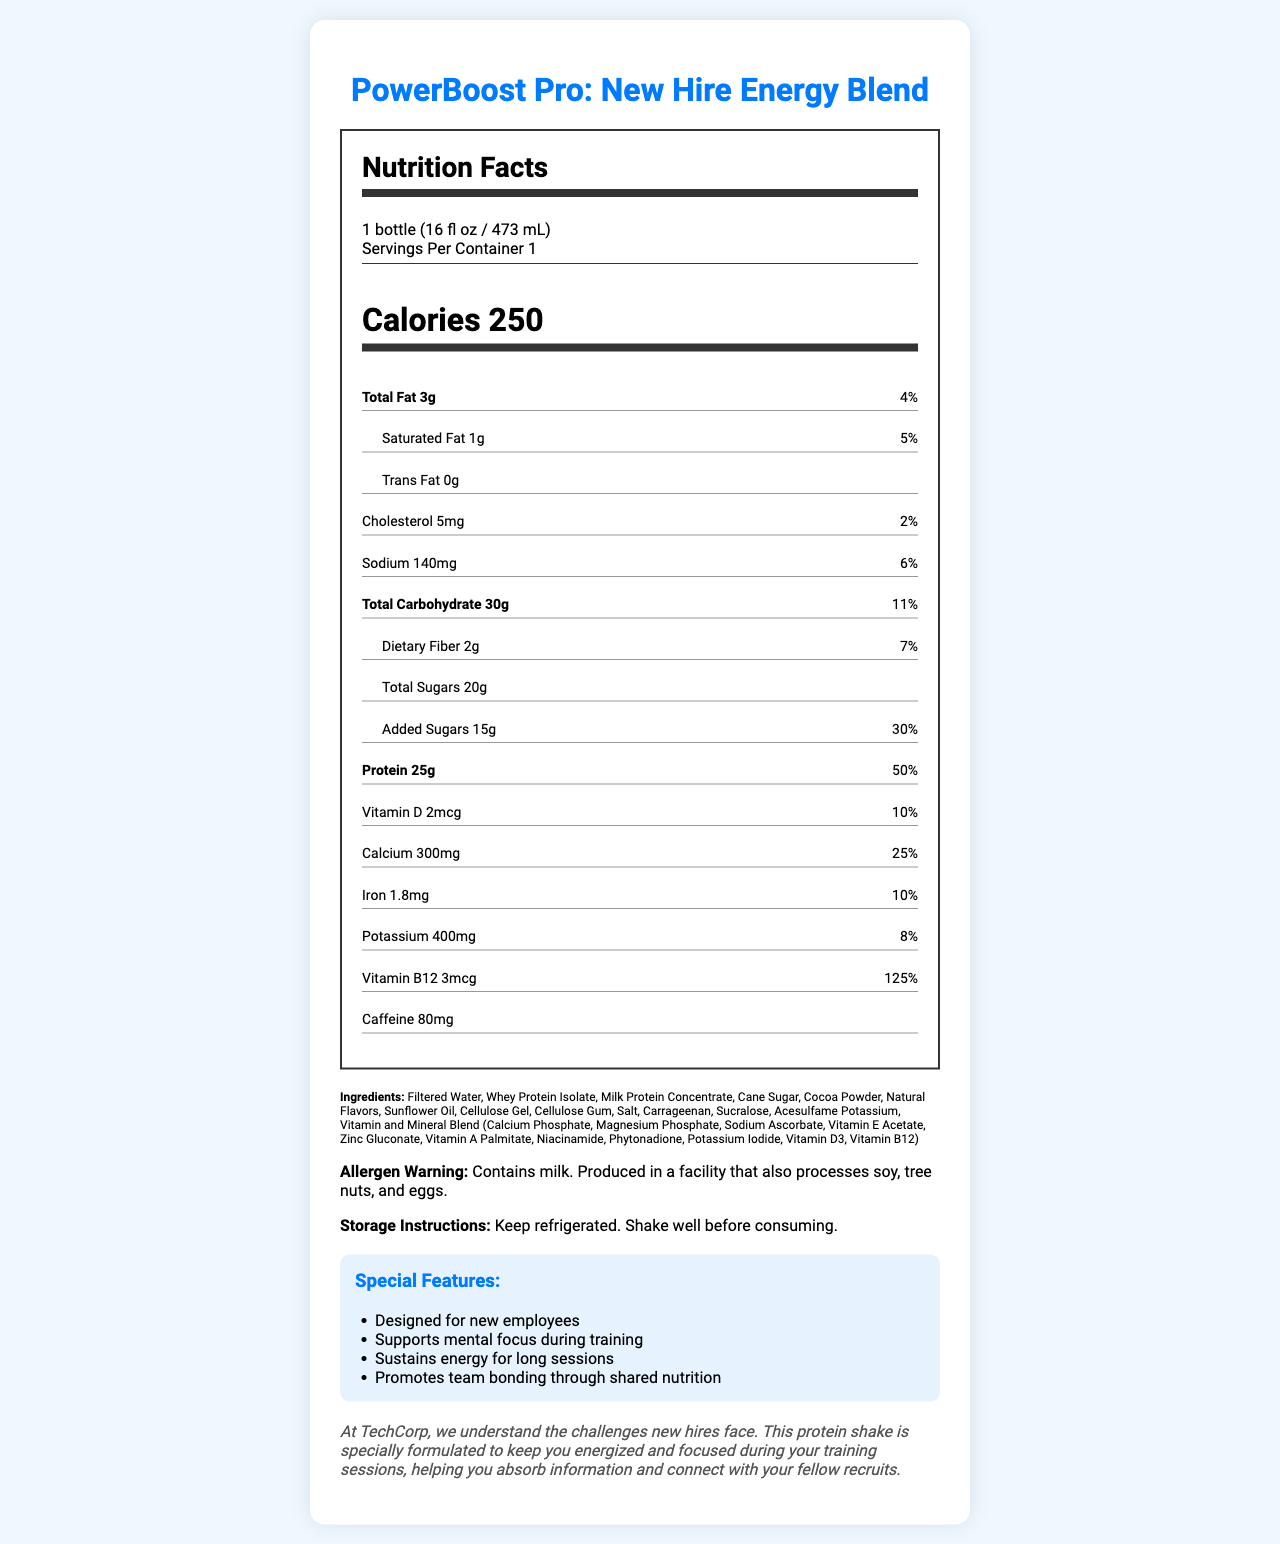what is the serving size for PowerBoost Pro: New Hire Energy Blend? The serving size is listed right below the product name at the top of the document.
Answer: 1 bottle (16 fl oz / 473 mL) how many calories are in one serving of PowerBoost Pro? The calories per serving are displayed prominently in a larger, bold font within the nutrition label section.
Answer: 250 what is the total fat content in the PowerBoost Pro? The total fat content is specifically listed in the nutrition facts section, just below the calories.
Answer: 3g how much protein does one serving of the PowerBoost Pro provide? The amount of protein per serving is displayed under the bold "Protein" label in the nutrition facts section.
Answer: 25g what is the caffeine content in the PowerBoost Pro? The caffeine content is clearly listed toward the bottom of the nutrition label.
Answer: 80mg does the PowerBoost Pro contain any vitamin B12? The nutrition label lists vitamin B12 with an amount of 3mcg and a daily value of 125%.
Answer: Yes what is the percentage of daily value for calcium provided by the PowerBoost Pro? The daily value percentage for calcium is listed in the nutrition facts section under calcium.
Answer: 25% which of the following ingredients is NOT included in the PowerBoost Pro?
A. Filtered Water
B. Soy Protein Isolate
C. Cocoa Powder Soy Protein Isolate is not listed among the ingredients. The correct options A and C are both listed.
Answer: B how much added sugars are in the PowerBoost Pro?
I. 10g
II. 15g
III. 20g The added sugars listed are 15g, which corresponds to option II.
Answer: II is PowerBoost Pro safe to consume if you have a soy allergy? The allergen warning indicates it contains milk and is produced in a facility that also processes soy. Therefore, it may not be safe for individuals with a soy allergy.
Answer: No summarize the key features and purpose of the PowerBoost Pro as described in the document. The summary incorporates the key purpose, special features, and some nutritional contents as described in the document.
Answer: PowerBoost Pro: New Hire Energy Blend is formulated to keep new recruits energized and focused during training. It supports mental focus and sustains energy for long sessions, promoting team bonding through shared nutrition. It contains 250 calories, 25g of protein, and 80mg of caffeine per serving, along with various vitamins and minerals. what is the expiration date of the PowerBoost Pro? The document does not provide information about the expiration date.
Answer: Cannot be determined 